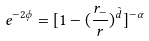<formula> <loc_0><loc_0><loc_500><loc_500>e ^ { - 2 \phi } = [ 1 - ( \frac { r _ { - } } { r } ) ^ { \tilde { d } } ] ^ { - \alpha }</formula> 